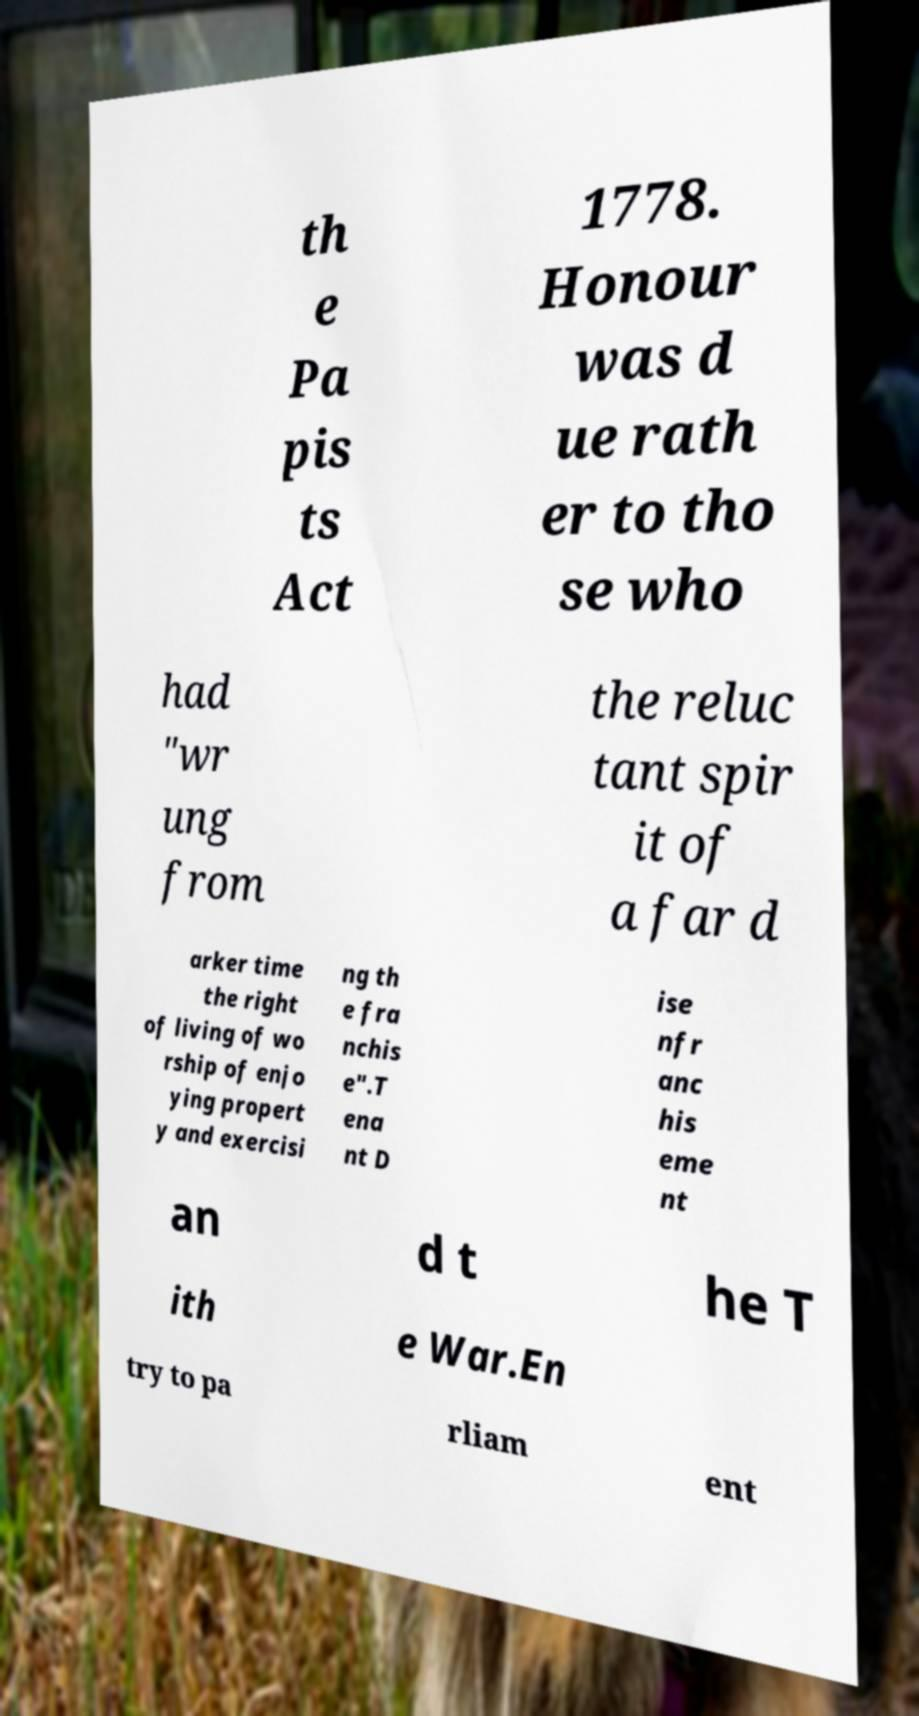Could you extract and type out the text from this image? th e Pa pis ts Act 1778. Honour was d ue rath er to tho se who had "wr ung from the reluc tant spir it of a far d arker time the right of living of wo rship of enjo ying propert y and exercisi ng th e fra nchis e".T ena nt D ise nfr anc his eme nt an d t he T ith e War.En try to pa rliam ent 